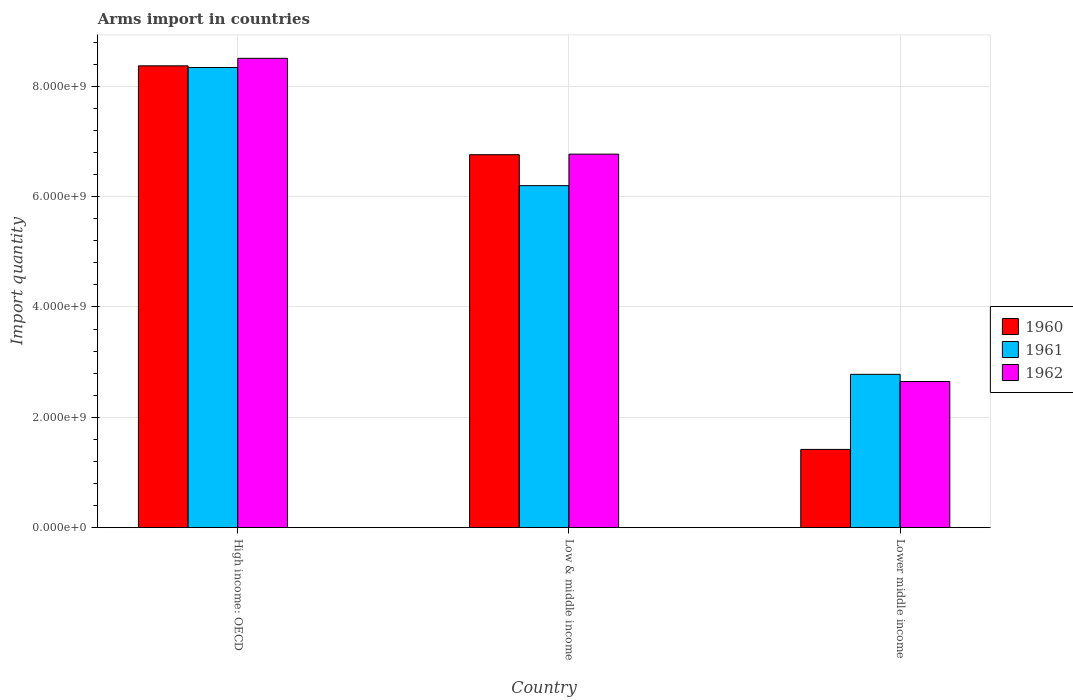How many different coloured bars are there?
Make the answer very short. 3. Are the number of bars on each tick of the X-axis equal?
Make the answer very short. Yes. How many bars are there on the 3rd tick from the left?
Make the answer very short. 3. How many bars are there on the 1st tick from the right?
Make the answer very short. 3. What is the label of the 1st group of bars from the left?
Your answer should be very brief. High income: OECD. In how many cases, is the number of bars for a given country not equal to the number of legend labels?
Your answer should be compact. 0. What is the total arms import in 1960 in High income: OECD?
Provide a succinct answer. 8.37e+09. Across all countries, what is the maximum total arms import in 1962?
Offer a very short reply. 8.51e+09. Across all countries, what is the minimum total arms import in 1961?
Ensure brevity in your answer.  2.78e+09. In which country was the total arms import in 1962 maximum?
Your response must be concise. High income: OECD. In which country was the total arms import in 1962 minimum?
Keep it short and to the point. Lower middle income. What is the total total arms import in 1961 in the graph?
Offer a terse response. 1.73e+1. What is the difference between the total arms import in 1961 in Low & middle income and that in Lower middle income?
Provide a succinct answer. 3.42e+09. What is the difference between the total arms import in 1962 in Lower middle income and the total arms import in 1961 in Low & middle income?
Keep it short and to the point. -3.55e+09. What is the average total arms import in 1962 per country?
Provide a short and direct response. 5.98e+09. What is the difference between the total arms import of/in 1960 and total arms import of/in 1962 in High income: OECD?
Make the answer very short. -1.36e+08. In how many countries, is the total arms import in 1962 greater than 400000000?
Make the answer very short. 3. What is the ratio of the total arms import in 1960 in High income: OECD to that in Low & middle income?
Provide a succinct answer. 1.24. Is the total arms import in 1961 in High income: OECD less than that in Lower middle income?
Your response must be concise. No. What is the difference between the highest and the second highest total arms import in 1960?
Offer a very short reply. 1.61e+09. What is the difference between the highest and the lowest total arms import in 1961?
Keep it short and to the point. 5.56e+09. Is the sum of the total arms import in 1960 in Low & middle income and Lower middle income greater than the maximum total arms import in 1961 across all countries?
Provide a short and direct response. No. What does the 2nd bar from the left in Low & middle income represents?
Provide a short and direct response. 1961. Are all the bars in the graph horizontal?
Your response must be concise. No. What is the difference between two consecutive major ticks on the Y-axis?
Keep it short and to the point. 2.00e+09. Are the values on the major ticks of Y-axis written in scientific E-notation?
Your response must be concise. Yes. Where does the legend appear in the graph?
Your answer should be compact. Center right. What is the title of the graph?
Your response must be concise. Arms import in countries. Does "1998" appear as one of the legend labels in the graph?
Keep it short and to the point. No. What is the label or title of the X-axis?
Your answer should be compact. Country. What is the label or title of the Y-axis?
Give a very brief answer. Import quantity. What is the Import quantity of 1960 in High income: OECD?
Your response must be concise. 8.37e+09. What is the Import quantity of 1961 in High income: OECD?
Offer a terse response. 8.34e+09. What is the Import quantity of 1962 in High income: OECD?
Make the answer very short. 8.51e+09. What is the Import quantity in 1960 in Low & middle income?
Your answer should be very brief. 6.76e+09. What is the Import quantity in 1961 in Low & middle income?
Provide a short and direct response. 6.20e+09. What is the Import quantity of 1962 in Low & middle income?
Make the answer very short. 6.77e+09. What is the Import quantity of 1960 in Lower middle income?
Your response must be concise. 1.42e+09. What is the Import quantity of 1961 in Lower middle income?
Keep it short and to the point. 2.78e+09. What is the Import quantity in 1962 in Lower middle income?
Ensure brevity in your answer.  2.65e+09. Across all countries, what is the maximum Import quantity in 1960?
Give a very brief answer. 8.37e+09. Across all countries, what is the maximum Import quantity of 1961?
Keep it short and to the point. 8.34e+09. Across all countries, what is the maximum Import quantity of 1962?
Give a very brief answer. 8.51e+09. Across all countries, what is the minimum Import quantity of 1960?
Your answer should be compact. 1.42e+09. Across all countries, what is the minimum Import quantity in 1961?
Keep it short and to the point. 2.78e+09. Across all countries, what is the minimum Import quantity of 1962?
Your response must be concise. 2.65e+09. What is the total Import quantity in 1960 in the graph?
Make the answer very short. 1.66e+1. What is the total Import quantity in 1961 in the graph?
Give a very brief answer. 1.73e+1. What is the total Import quantity in 1962 in the graph?
Your response must be concise. 1.79e+1. What is the difference between the Import quantity in 1960 in High income: OECD and that in Low & middle income?
Your answer should be very brief. 1.61e+09. What is the difference between the Import quantity in 1961 in High income: OECD and that in Low & middle income?
Provide a succinct answer. 2.14e+09. What is the difference between the Import quantity of 1962 in High income: OECD and that in Low & middle income?
Provide a succinct answer. 1.74e+09. What is the difference between the Import quantity in 1960 in High income: OECD and that in Lower middle income?
Offer a terse response. 6.95e+09. What is the difference between the Import quantity in 1961 in High income: OECD and that in Lower middle income?
Your response must be concise. 5.56e+09. What is the difference between the Import quantity of 1962 in High income: OECD and that in Lower middle income?
Your answer should be very brief. 5.86e+09. What is the difference between the Import quantity of 1960 in Low & middle income and that in Lower middle income?
Keep it short and to the point. 5.34e+09. What is the difference between the Import quantity in 1961 in Low & middle income and that in Lower middle income?
Give a very brief answer. 3.42e+09. What is the difference between the Import quantity in 1962 in Low & middle income and that in Lower middle income?
Your response must be concise. 4.12e+09. What is the difference between the Import quantity in 1960 in High income: OECD and the Import quantity in 1961 in Low & middle income?
Offer a terse response. 2.17e+09. What is the difference between the Import quantity of 1960 in High income: OECD and the Import quantity of 1962 in Low & middle income?
Provide a short and direct response. 1.60e+09. What is the difference between the Import quantity of 1961 in High income: OECD and the Import quantity of 1962 in Low & middle income?
Your answer should be very brief. 1.57e+09. What is the difference between the Import quantity in 1960 in High income: OECD and the Import quantity in 1961 in Lower middle income?
Make the answer very short. 5.59e+09. What is the difference between the Import quantity in 1960 in High income: OECD and the Import quantity in 1962 in Lower middle income?
Your response must be concise. 5.72e+09. What is the difference between the Import quantity in 1961 in High income: OECD and the Import quantity in 1962 in Lower middle income?
Your answer should be compact. 5.69e+09. What is the difference between the Import quantity of 1960 in Low & middle income and the Import quantity of 1961 in Lower middle income?
Your response must be concise. 3.98e+09. What is the difference between the Import quantity of 1960 in Low & middle income and the Import quantity of 1962 in Lower middle income?
Provide a succinct answer. 4.11e+09. What is the difference between the Import quantity of 1961 in Low & middle income and the Import quantity of 1962 in Lower middle income?
Offer a very short reply. 3.55e+09. What is the average Import quantity of 1960 per country?
Your answer should be very brief. 5.52e+09. What is the average Import quantity in 1961 per country?
Your response must be concise. 5.77e+09. What is the average Import quantity in 1962 per country?
Ensure brevity in your answer.  5.98e+09. What is the difference between the Import quantity of 1960 and Import quantity of 1961 in High income: OECD?
Your answer should be compact. 3.00e+07. What is the difference between the Import quantity in 1960 and Import quantity in 1962 in High income: OECD?
Your answer should be compact. -1.36e+08. What is the difference between the Import quantity of 1961 and Import quantity of 1962 in High income: OECD?
Provide a short and direct response. -1.66e+08. What is the difference between the Import quantity of 1960 and Import quantity of 1961 in Low & middle income?
Ensure brevity in your answer.  5.61e+08. What is the difference between the Import quantity in 1960 and Import quantity in 1962 in Low & middle income?
Your answer should be compact. -1.00e+07. What is the difference between the Import quantity of 1961 and Import quantity of 1962 in Low & middle income?
Keep it short and to the point. -5.71e+08. What is the difference between the Import quantity of 1960 and Import quantity of 1961 in Lower middle income?
Keep it short and to the point. -1.36e+09. What is the difference between the Import quantity in 1960 and Import quantity in 1962 in Lower middle income?
Your answer should be very brief. -1.23e+09. What is the difference between the Import quantity in 1961 and Import quantity in 1962 in Lower middle income?
Offer a very short reply. 1.30e+08. What is the ratio of the Import quantity in 1960 in High income: OECD to that in Low & middle income?
Keep it short and to the point. 1.24. What is the ratio of the Import quantity in 1961 in High income: OECD to that in Low & middle income?
Ensure brevity in your answer.  1.35. What is the ratio of the Import quantity in 1962 in High income: OECD to that in Low & middle income?
Provide a succinct answer. 1.26. What is the ratio of the Import quantity in 1960 in High income: OECD to that in Lower middle income?
Make the answer very short. 5.9. What is the ratio of the Import quantity of 1961 in High income: OECD to that in Lower middle income?
Provide a succinct answer. 3. What is the ratio of the Import quantity in 1962 in High income: OECD to that in Lower middle income?
Your answer should be very brief. 3.21. What is the ratio of the Import quantity in 1960 in Low & middle income to that in Lower middle income?
Make the answer very short. 4.77. What is the ratio of the Import quantity of 1961 in Low & middle income to that in Lower middle income?
Provide a short and direct response. 2.23. What is the ratio of the Import quantity in 1962 in Low & middle income to that in Lower middle income?
Offer a very short reply. 2.56. What is the difference between the highest and the second highest Import quantity of 1960?
Ensure brevity in your answer.  1.61e+09. What is the difference between the highest and the second highest Import quantity in 1961?
Your answer should be compact. 2.14e+09. What is the difference between the highest and the second highest Import quantity in 1962?
Ensure brevity in your answer.  1.74e+09. What is the difference between the highest and the lowest Import quantity of 1960?
Ensure brevity in your answer.  6.95e+09. What is the difference between the highest and the lowest Import quantity in 1961?
Make the answer very short. 5.56e+09. What is the difference between the highest and the lowest Import quantity in 1962?
Your answer should be compact. 5.86e+09. 